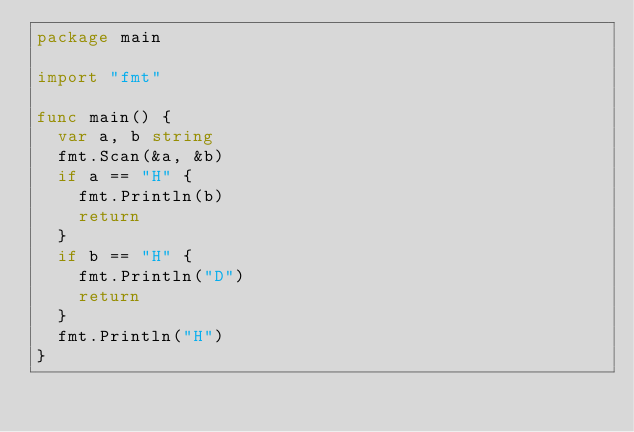<code> <loc_0><loc_0><loc_500><loc_500><_Go_>package main

import "fmt"

func main() {
	var a, b string
	fmt.Scan(&a, &b)
	if a == "H" {
		fmt.Println(b)
		return
	}
	if b == "H" {
		fmt.Println("D")
		return
	}
	fmt.Println("H")
}
</code> 